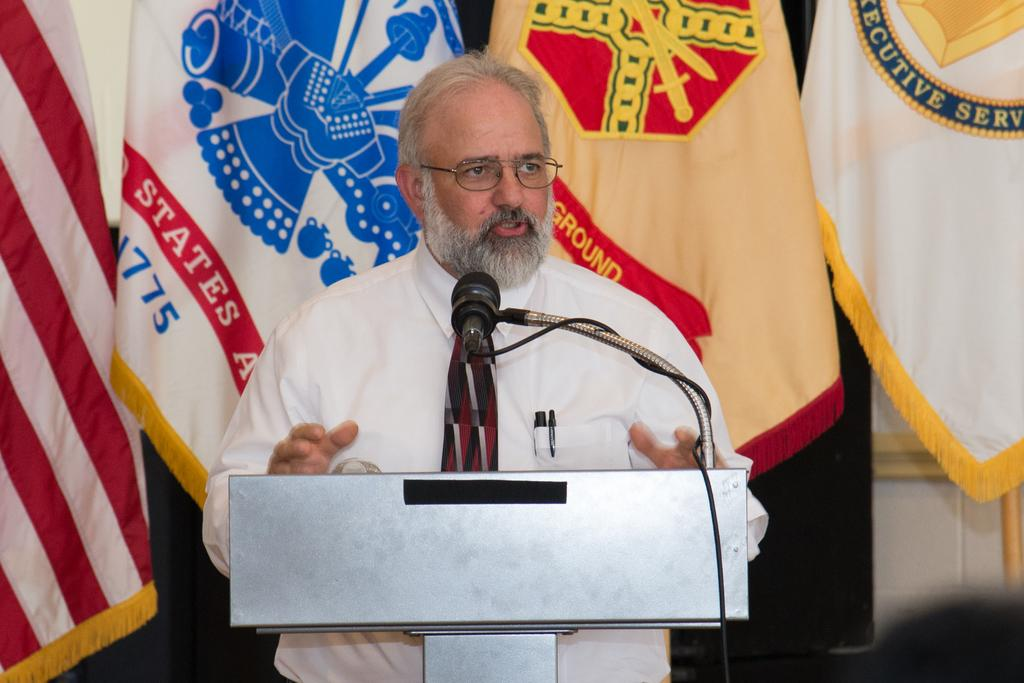<image>
Share a concise interpretation of the image provided. A man stands behind a podium with a flag behind him that has "States" on a red background. 